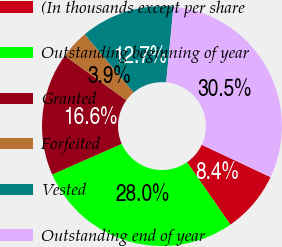Convert chart to OTSL. <chart><loc_0><loc_0><loc_500><loc_500><pie_chart><fcel>(In thousands except per share<fcel>Outstanding beginning of year<fcel>Granted<fcel>Forfeited<fcel>Vested<fcel>Outstanding end of year<nl><fcel>8.36%<fcel>28.04%<fcel>16.6%<fcel>3.88%<fcel>12.67%<fcel>30.46%<nl></chart> 